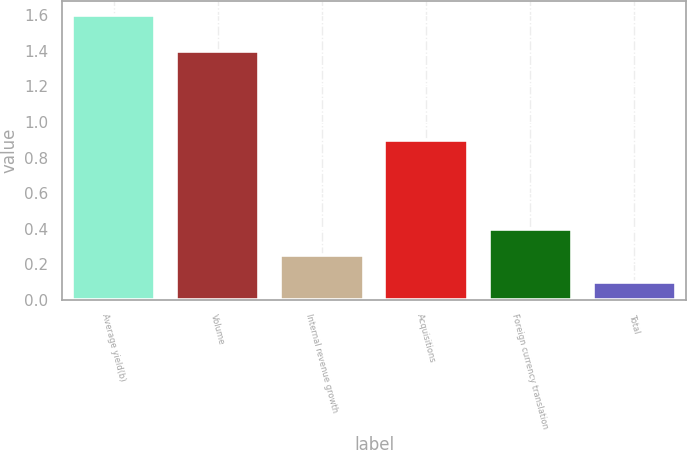<chart> <loc_0><loc_0><loc_500><loc_500><bar_chart><fcel>Average yield(b)<fcel>Volume<fcel>Internal revenue growth<fcel>Acquisitions<fcel>Foreign currency translation<fcel>Total<nl><fcel>1.6<fcel>1.4<fcel>0.25<fcel>0.9<fcel>0.4<fcel>0.1<nl></chart> 